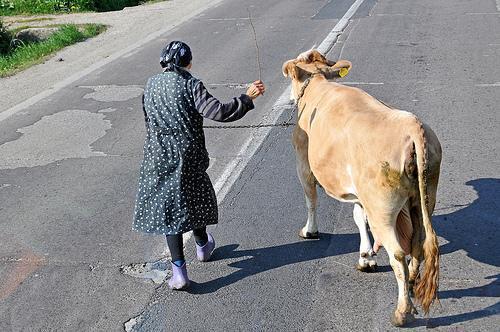How many cows are on the road?
Give a very brief answer. 1. 